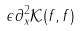<formula> <loc_0><loc_0><loc_500><loc_500>\epsilon \partial ^ { 2 } _ { x } \mathcal { K } ( f , f )</formula> 